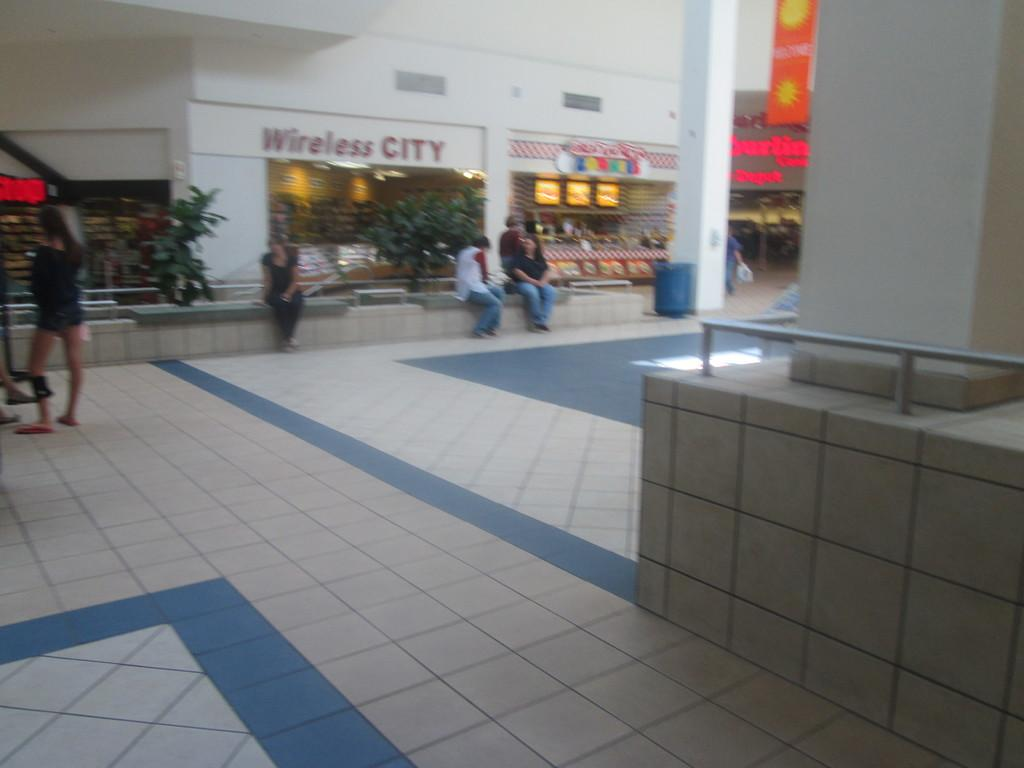What are the people in the image doing? There is a group of people sitting on a wall in the image. Can you describe the woman in the image? There is a woman standing on the floor in the image. What can be seen in the background of the image? There is a group of plants and a building in the background of the image. What is the woman's belief about her partner's uncle in the image? There is no information about the woman's beliefs or her partner's uncle in the image. 